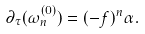<formula> <loc_0><loc_0><loc_500><loc_500>\partial _ { \tau } ( \omega ^ { ( 0 ) } _ { n } ) = ( - f ) ^ { n } \alpha .</formula> 